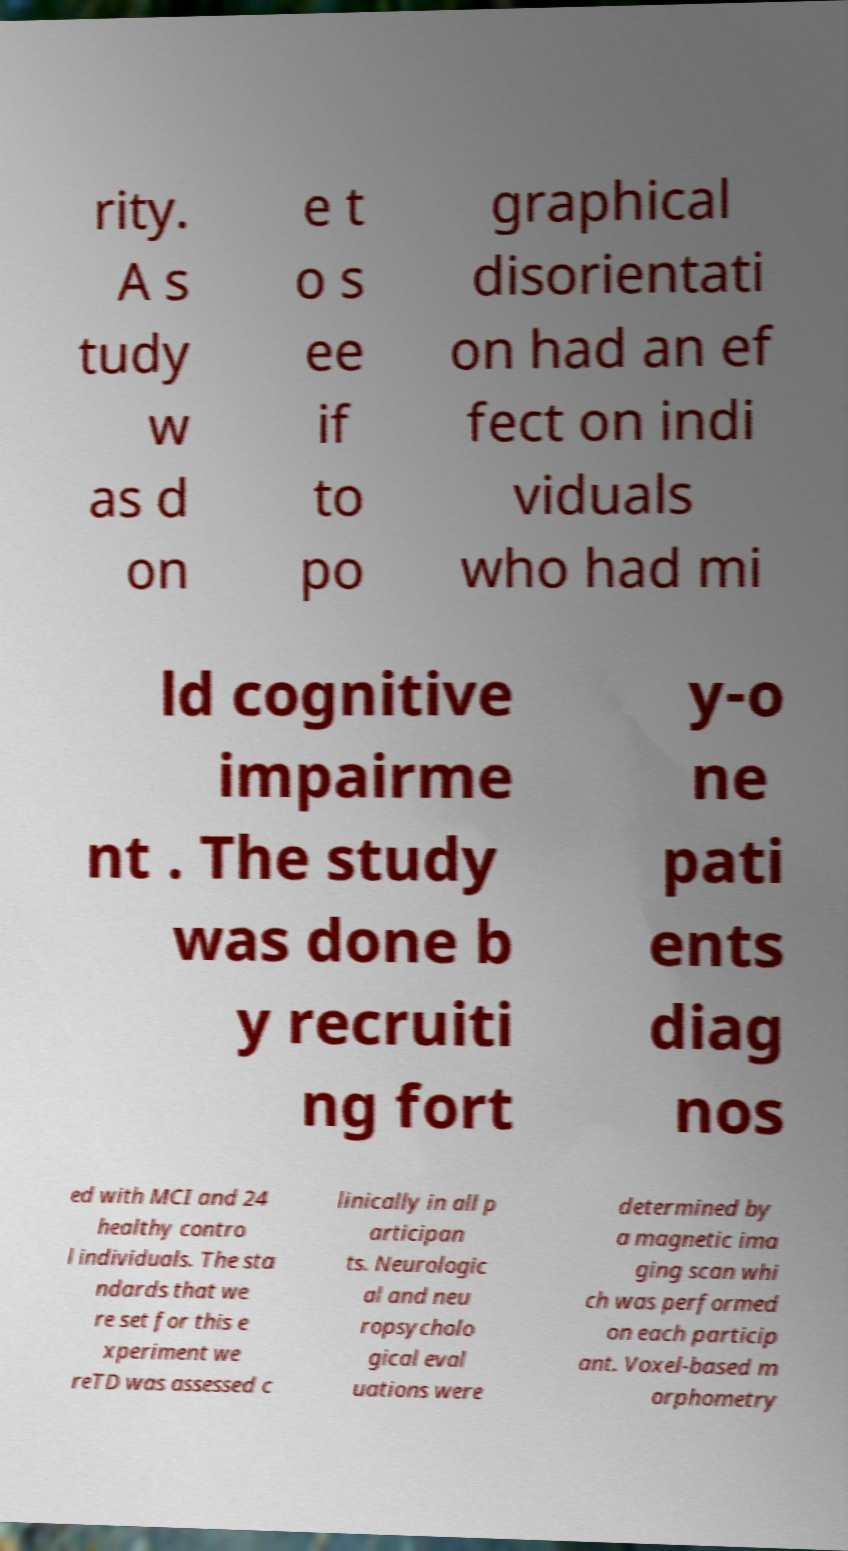Please identify and transcribe the text found in this image. rity. A s tudy w as d on e t o s ee if to po graphical disorientati on had an ef fect on indi viduals who had mi ld cognitive impairme nt . The study was done b y recruiti ng fort y-o ne pati ents diag nos ed with MCI and 24 healthy contro l individuals. The sta ndards that we re set for this e xperiment we reTD was assessed c linically in all p articipan ts. Neurologic al and neu ropsycholo gical eval uations were determined by a magnetic ima ging scan whi ch was performed on each particip ant. Voxel-based m orphometry 